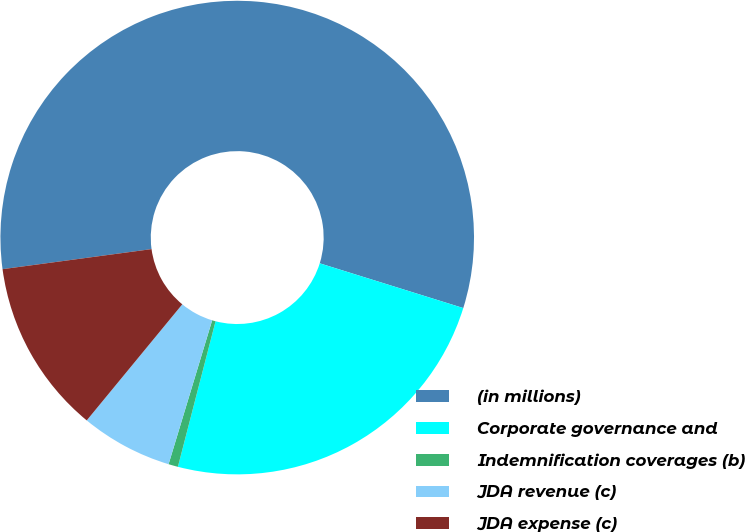Convert chart to OTSL. <chart><loc_0><loc_0><loc_500><loc_500><pie_chart><fcel>(in millions)<fcel>Corporate governance and<fcel>Indemnification coverages (b)<fcel>JDA revenue (c)<fcel>JDA expense (c)<nl><fcel>56.94%<fcel>24.22%<fcel>0.65%<fcel>6.28%<fcel>11.91%<nl></chart> 